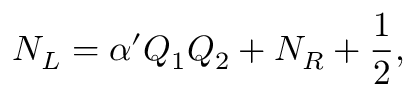Convert formula to latex. <formula><loc_0><loc_0><loc_500><loc_500>N _ { L } = \alpha ^ { \prime } Q _ { 1 } Q _ { 2 } + N _ { R } + { \frac { 1 } { 2 } } ,</formula> 